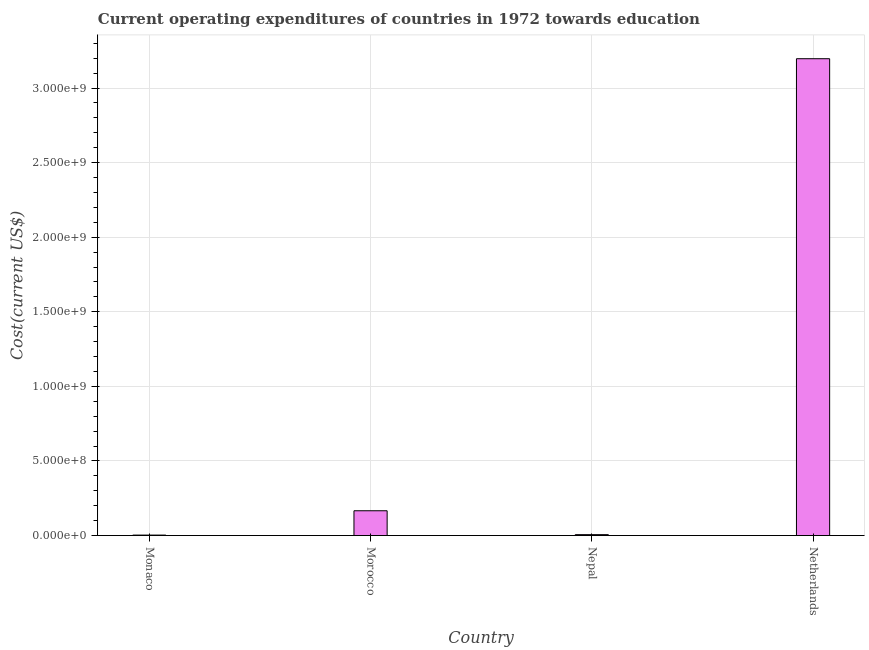Does the graph contain any zero values?
Give a very brief answer. No. Does the graph contain grids?
Ensure brevity in your answer.  Yes. What is the title of the graph?
Give a very brief answer. Current operating expenditures of countries in 1972 towards education. What is the label or title of the X-axis?
Your answer should be compact. Country. What is the label or title of the Y-axis?
Offer a very short reply. Cost(current US$). What is the education expenditure in Nepal?
Your answer should be very brief. 6.14e+06. Across all countries, what is the maximum education expenditure?
Offer a terse response. 3.20e+09. Across all countries, what is the minimum education expenditure?
Offer a terse response. 3.22e+06. In which country was the education expenditure maximum?
Provide a short and direct response. Netherlands. In which country was the education expenditure minimum?
Provide a short and direct response. Monaco. What is the sum of the education expenditure?
Provide a succinct answer. 3.37e+09. What is the difference between the education expenditure in Monaco and Morocco?
Keep it short and to the point. -1.63e+08. What is the average education expenditure per country?
Ensure brevity in your answer.  8.43e+08. What is the median education expenditure?
Ensure brevity in your answer.  8.62e+07. In how many countries, is the education expenditure greater than 2600000000 US$?
Offer a very short reply. 1. What is the ratio of the education expenditure in Morocco to that in Nepal?
Provide a succinct answer. 27.05. Is the difference between the education expenditure in Monaco and Netherlands greater than the difference between any two countries?
Give a very brief answer. Yes. What is the difference between the highest and the second highest education expenditure?
Give a very brief answer. 3.03e+09. What is the difference between the highest and the lowest education expenditure?
Give a very brief answer. 3.19e+09. Are all the bars in the graph horizontal?
Your answer should be compact. No. Are the values on the major ticks of Y-axis written in scientific E-notation?
Your answer should be compact. Yes. What is the Cost(current US$) in Monaco?
Provide a succinct answer. 3.22e+06. What is the Cost(current US$) of Morocco?
Give a very brief answer. 1.66e+08. What is the Cost(current US$) in Nepal?
Your answer should be very brief. 6.14e+06. What is the Cost(current US$) of Netherlands?
Offer a terse response. 3.20e+09. What is the difference between the Cost(current US$) in Monaco and Morocco?
Your answer should be very brief. -1.63e+08. What is the difference between the Cost(current US$) in Monaco and Nepal?
Your answer should be compact. -2.92e+06. What is the difference between the Cost(current US$) in Monaco and Netherlands?
Keep it short and to the point. -3.19e+09. What is the difference between the Cost(current US$) in Morocco and Nepal?
Ensure brevity in your answer.  1.60e+08. What is the difference between the Cost(current US$) in Morocco and Netherlands?
Offer a very short reply. -3.03e+09. What is the difference between the Cost(current US$) in Nepal and Netherlands?
Provide a short and direct response. -3.19e+09. What is the ratio of the Cost(current US$) in Monaco to that in Morocco?
Keep it short and to the point. 0.02. What is the ratio of the Cost(current US$) in Monaco to that in Nepal?
Your answer should be very brief. 0.52. What is the ratio of the Cost(current US$) in Monaco to that in Netherlands?
Give a very brief answer. 0. What is the ratio of the Cost(current US$) in Morocco to that in Nepal?
Your answer should be very brief. 27.05. What is the ratio of the Cost(current US$) in Morocco to that in Netherlands?
Your response must be concise. 0.05. What is the ratio of the Cost(current US$) in Nepal to that in Netherlands?
Give a very brief answer. 0. 